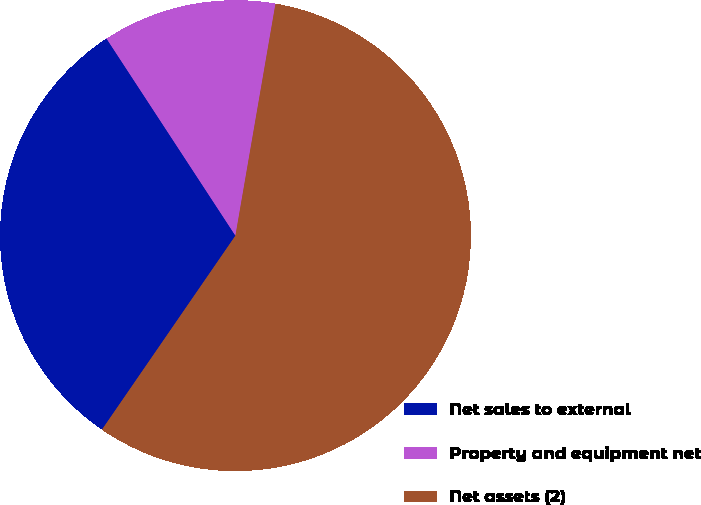<chart> <loc_0><loc_0><loc_500><loc_500><pie_chart><fcel>Net sales to external<fcel>Property and equipment net<fcel>Net assets (2)<nl><fcel>31.19%<fcel>11.94%<fcel>56.87%<nl></chart> 